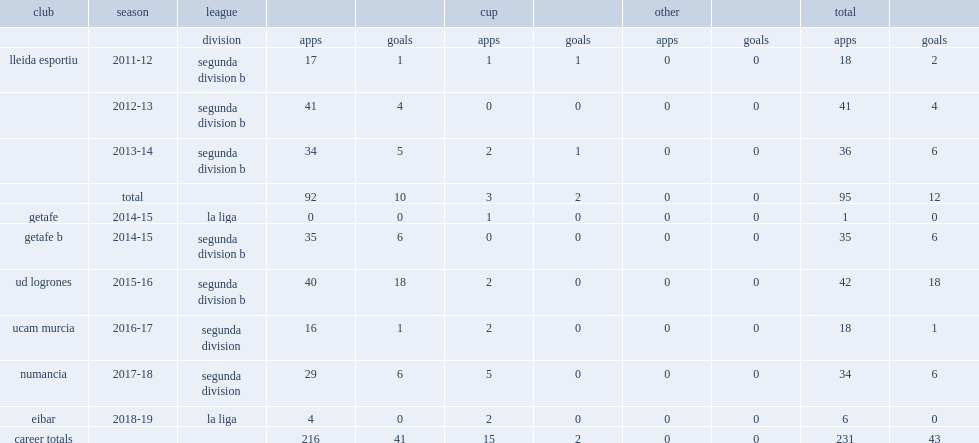When did milla move to getafe after he joined lleida esportiu and made his debut in segunda division b? 2014-15. 